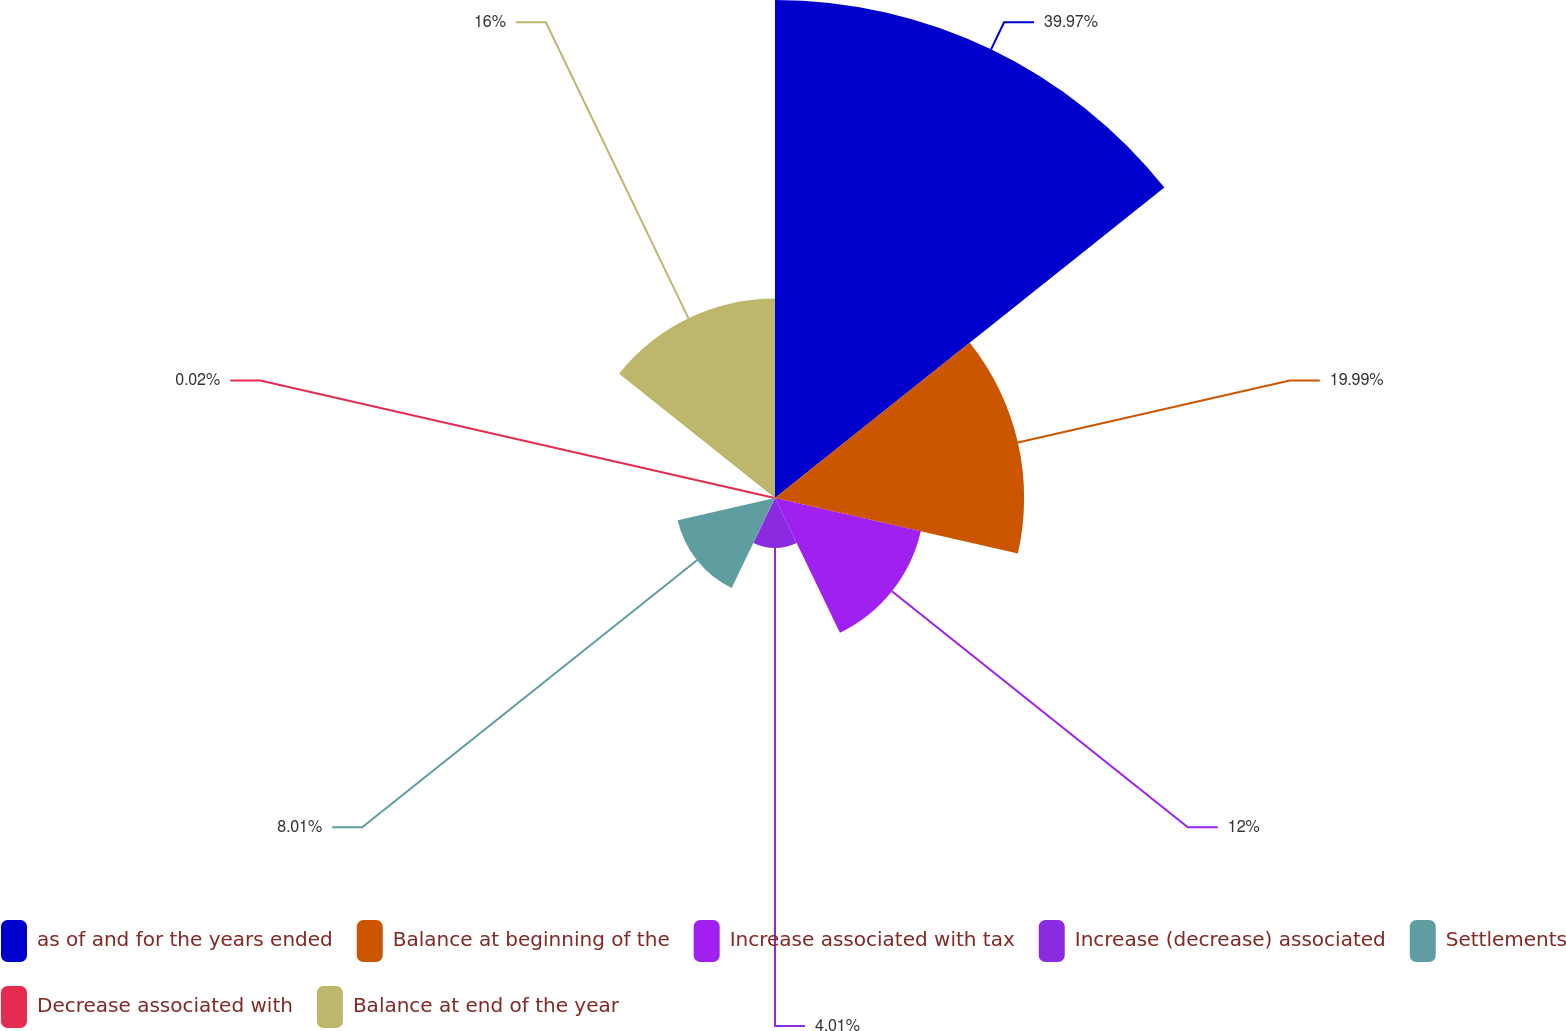Convert chart to OTSL. <chart><loc_0><loc_0><loc_500><loc_500><pie_chart><fcel>as of and for the years ended<fcel>Balance at beginning of the<fcel>Increase associated with tax<fcel>Increase (decrease) associated<fcel>Settlements<fcel>Decrease associated with<fcel>Balance at end of the year<nl><fcel>39.96%<fcel>19.99%<fcel>12.0%<fcel>4.01%<fcel>8.01%<fcel>0.02%<fcel>16.0%<nl></chart> 